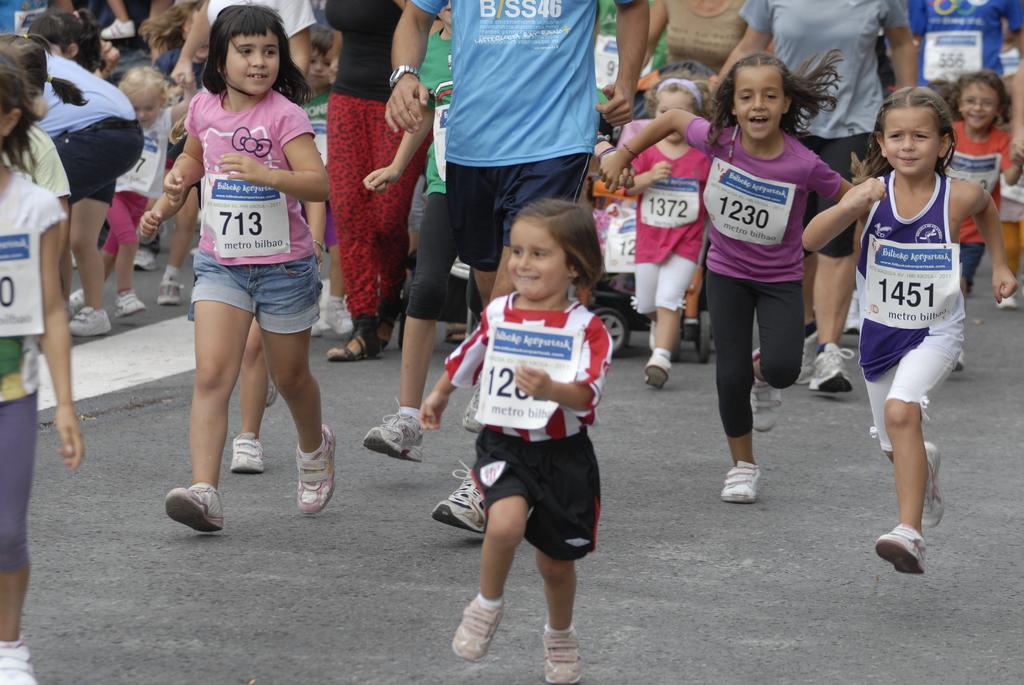What is the number of the girl with the pink shirt and jean shorts?
Provide a short and direct response. 713. 